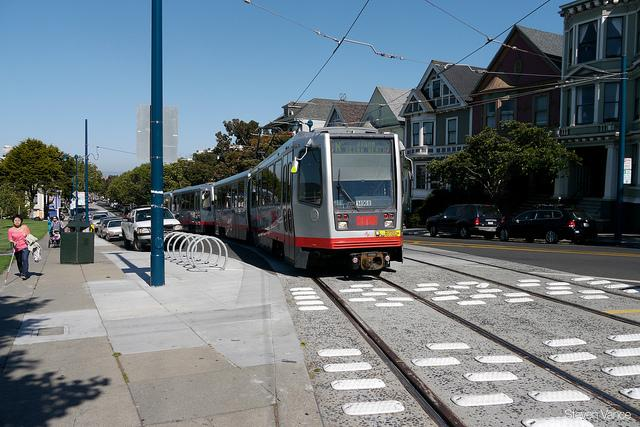The person nearest has what handicap? blind 